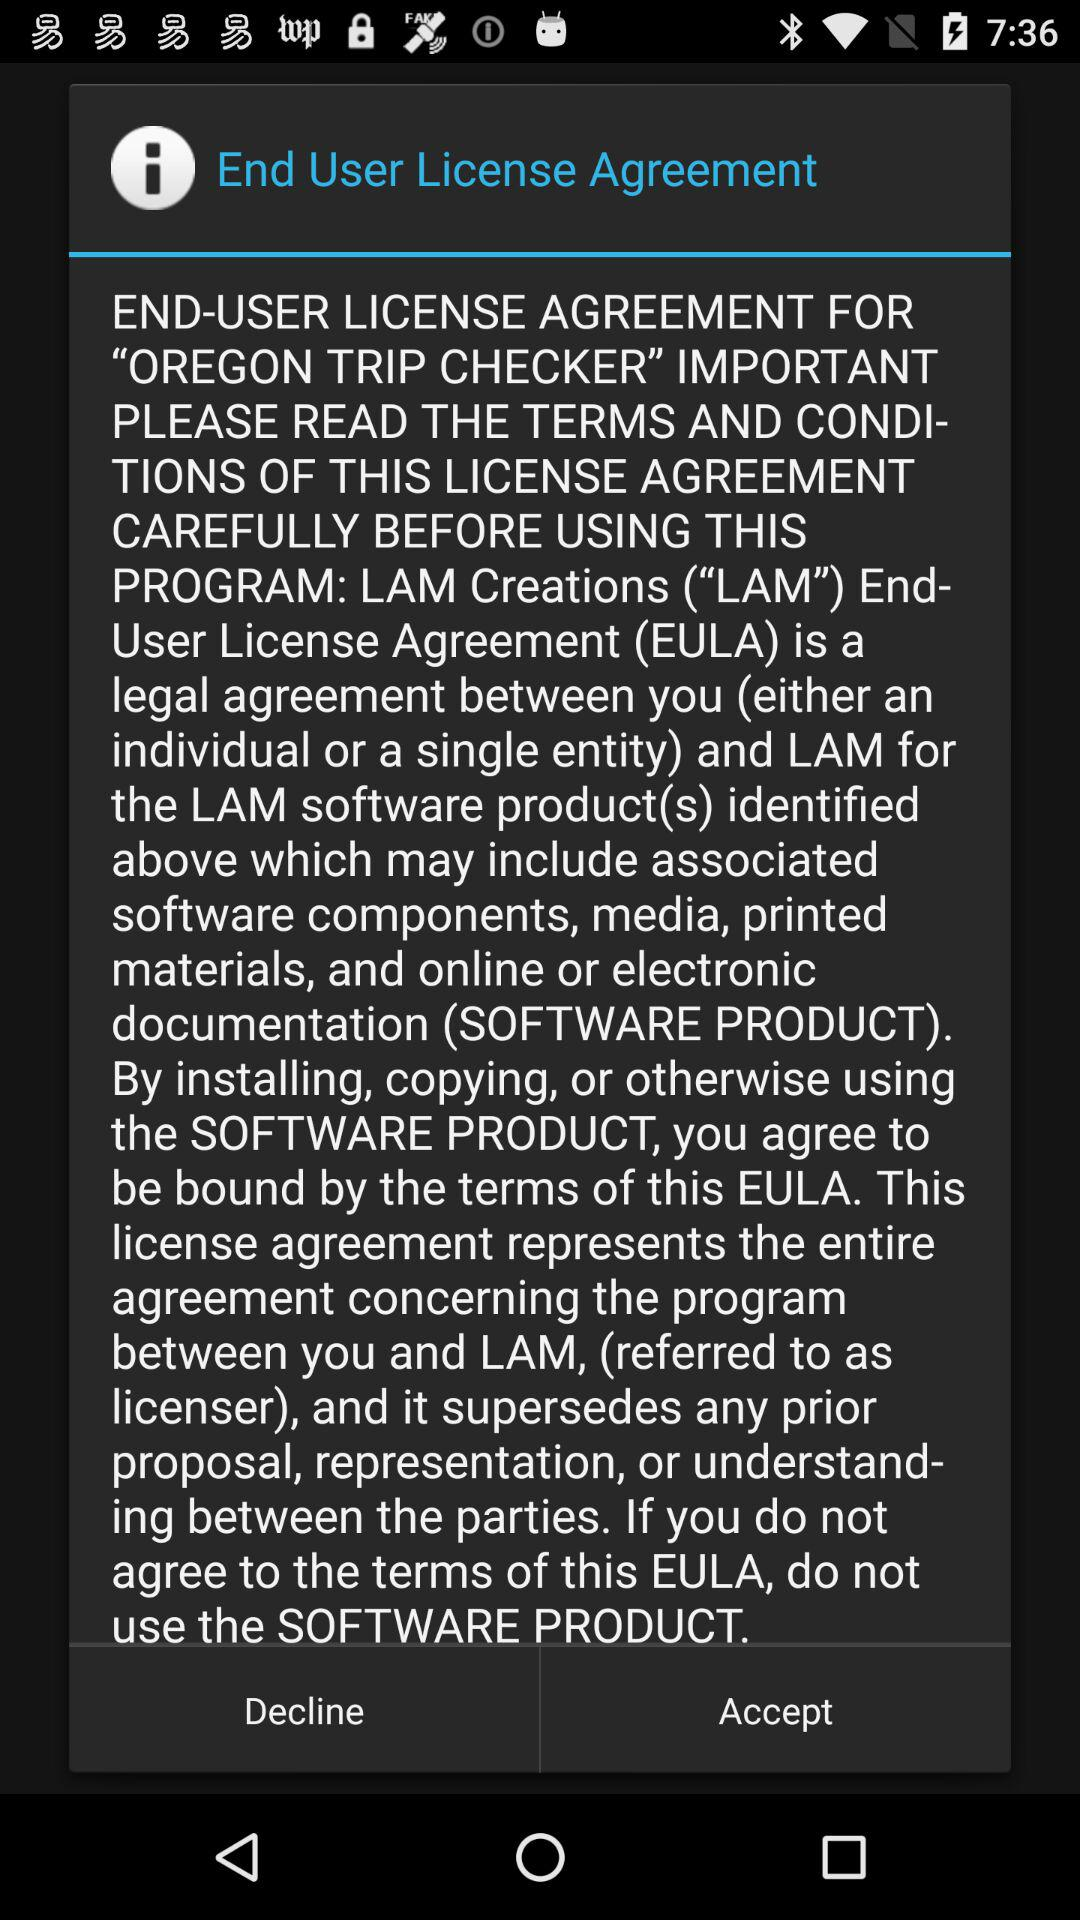What is the agreement's name? The agreement's name is the End User License Agreement. 